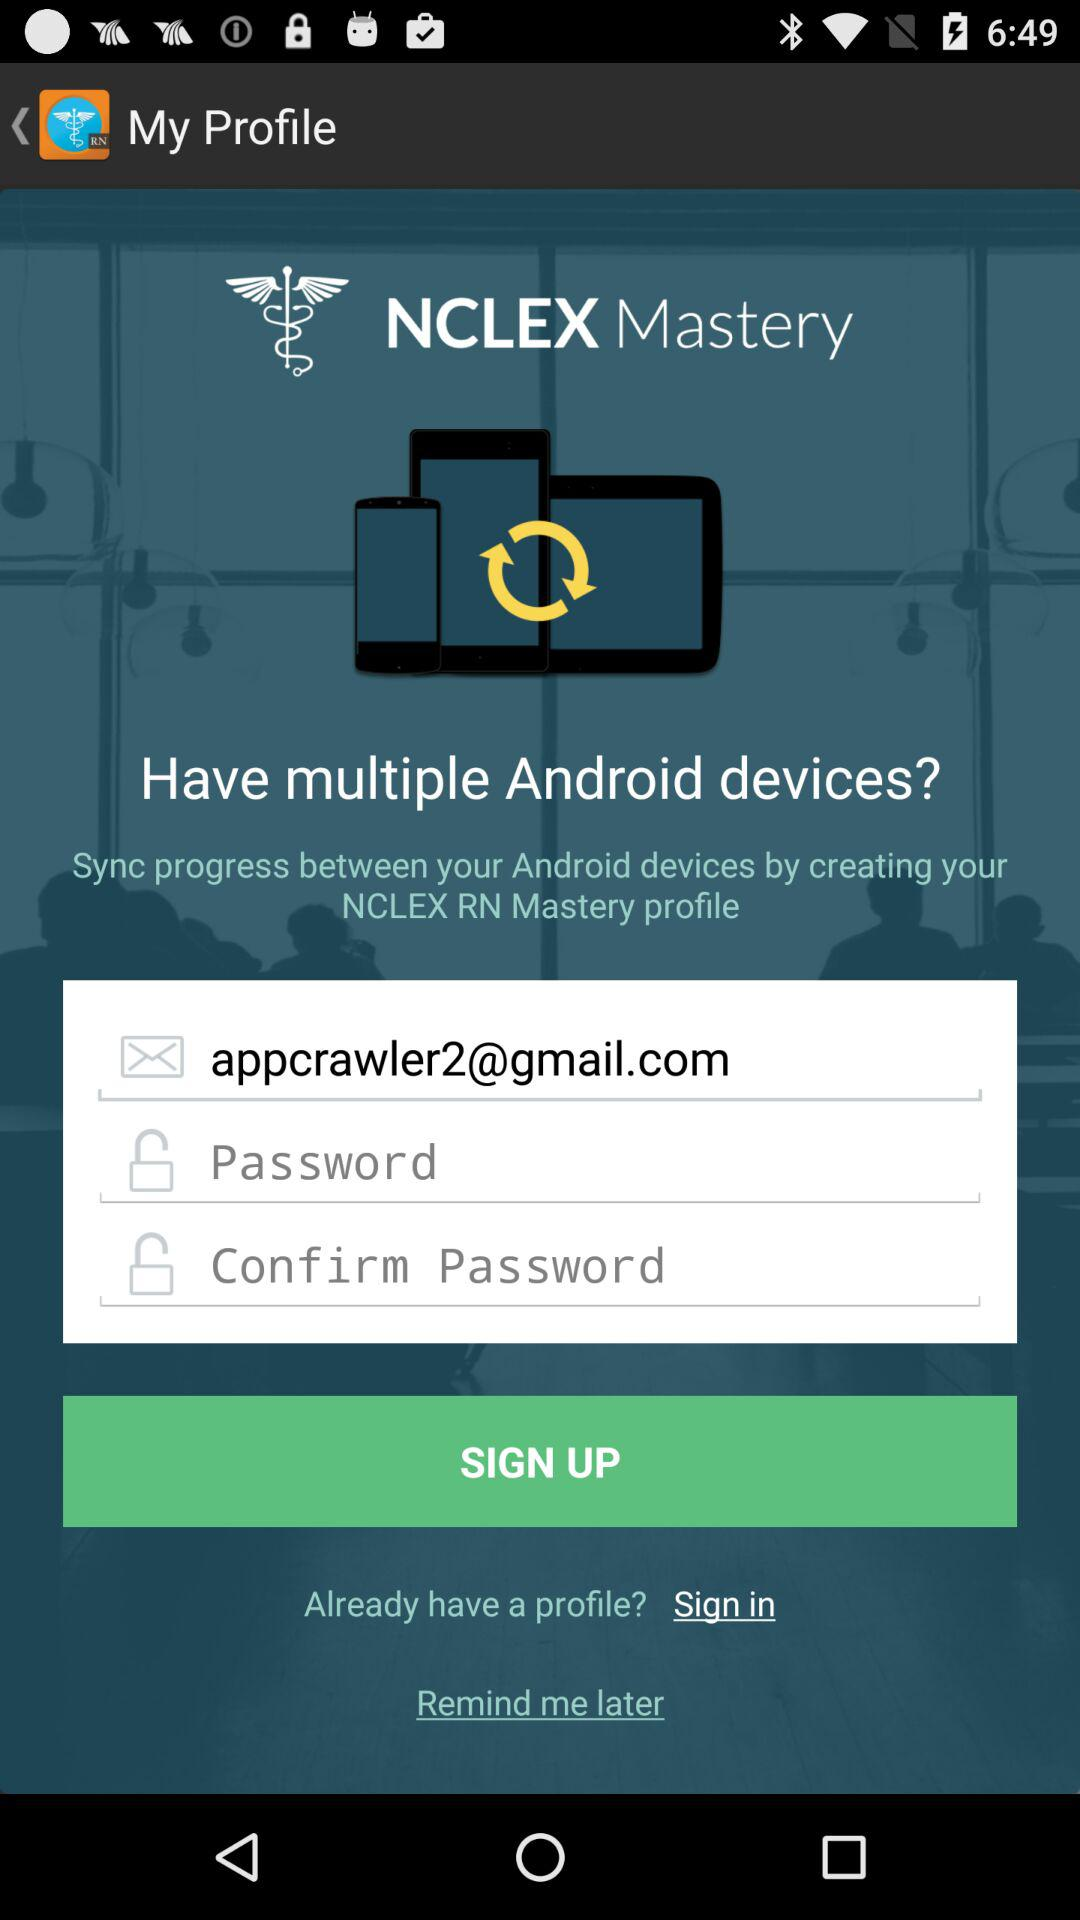How many steps are there in the account creation process?
Answer the question using a single word or phrase. 3 